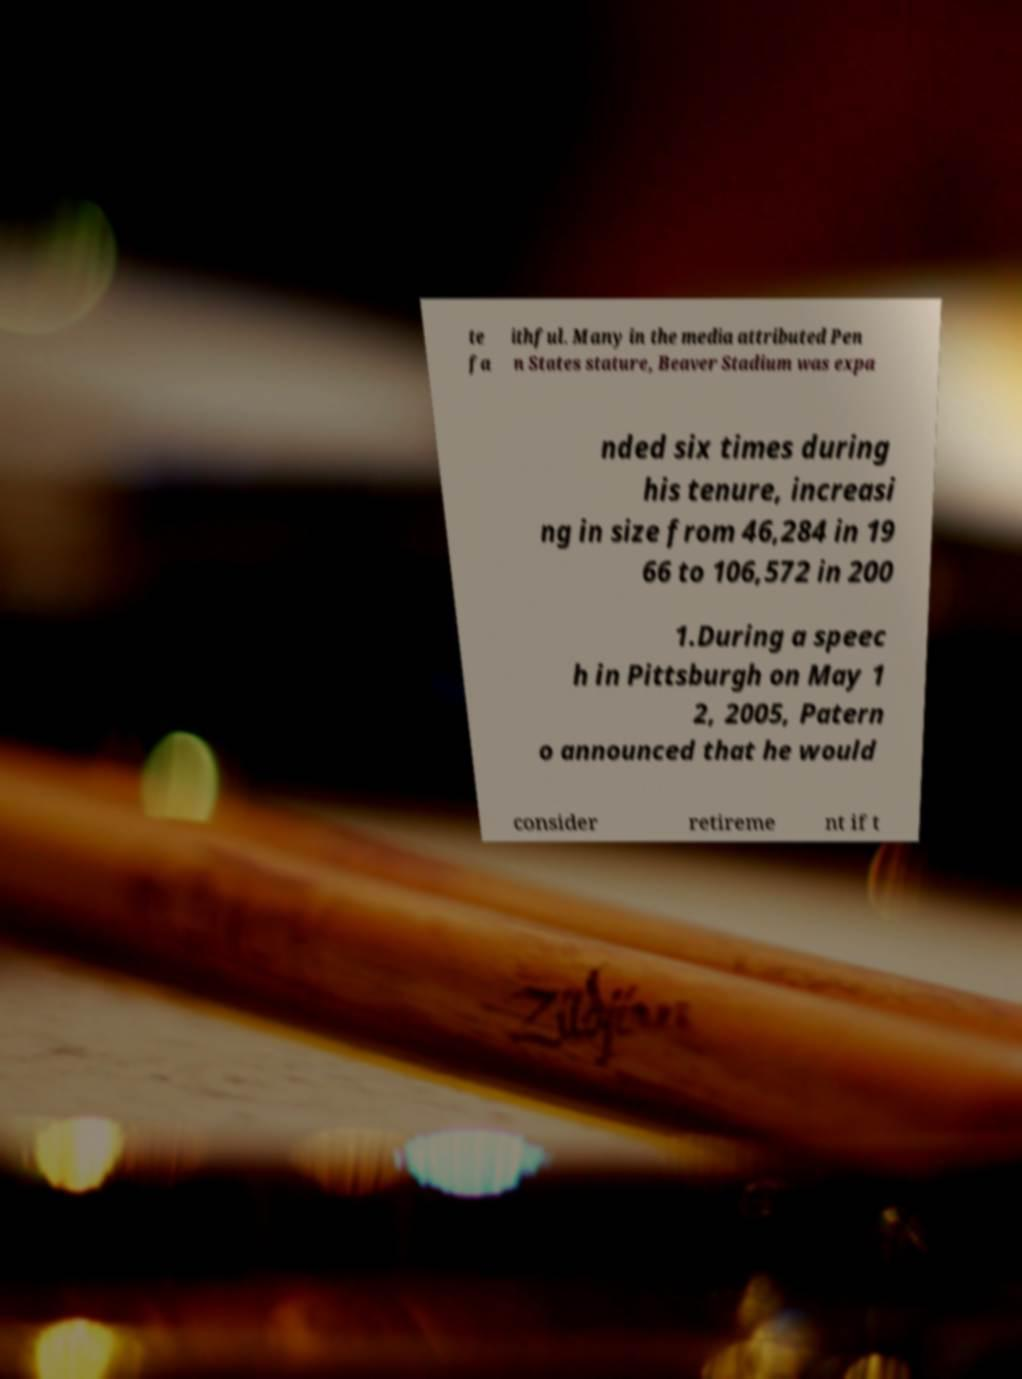Please identify and transcribe the text found in this image. te fa ithful. Many in the media attributed Pen n States stature, Beaver Stadium was expa nded six times during his tenure, increasi ng in size from 46,284 in 19 66 to 106,572 in 200 1.During a speec h in Pittsburgh on May 1 2, 2005, Patern o announced that he would consider retireme nt if t 